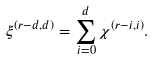<formula> <loc_0><loc_0><loc_500><loc_500>\xi ^ { ( r - d , d ) } = \sum _ { i = 0 } ^ { d } \chi ^ { ( r - i , i ) } .</formula> 